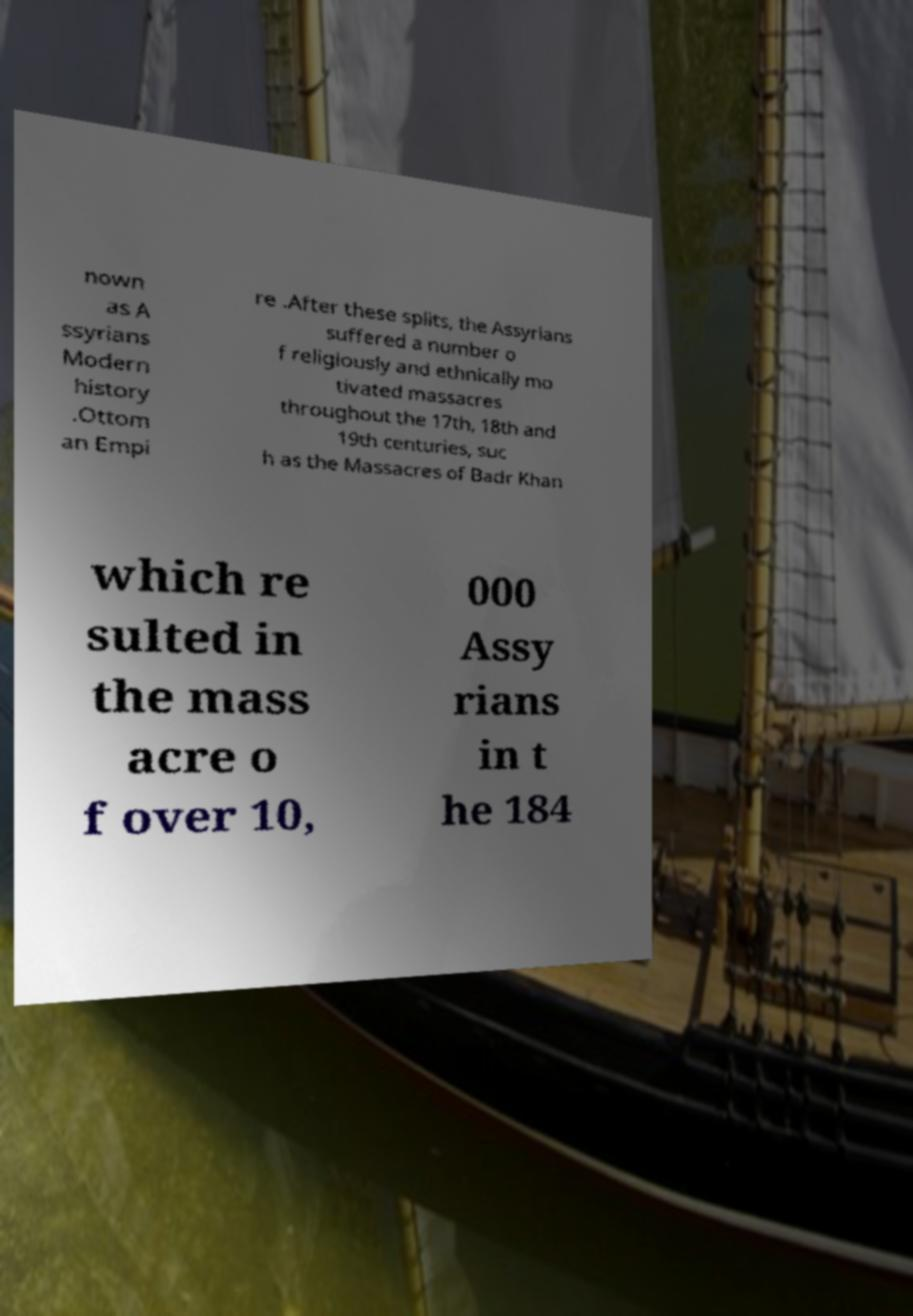Can you read and provide the text displayed in the image?This photo seems to have some interesting text. Can you extract and type it out for me? nown as A ssyrians Modern history .Ottom an Empi re .After these splits, the Assyrians suffered a number o f religiously and ethnically mo tivated massacres throughout the 17th, 18th and 19th centuries, suc h as the Massacres of Badr Khan which re sulted in the mass acre o f over 10, 000 Assy rians in t he 184 